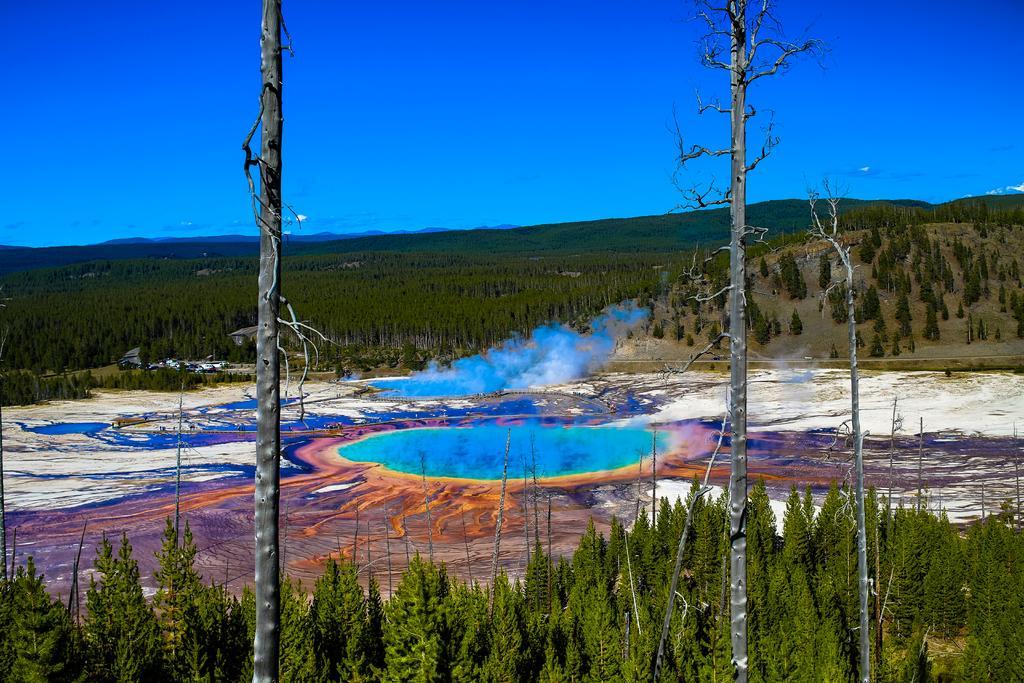Can you describe this image briefly? In this image I can see number of trees, blue colour smoke and in background I can see the sky. 